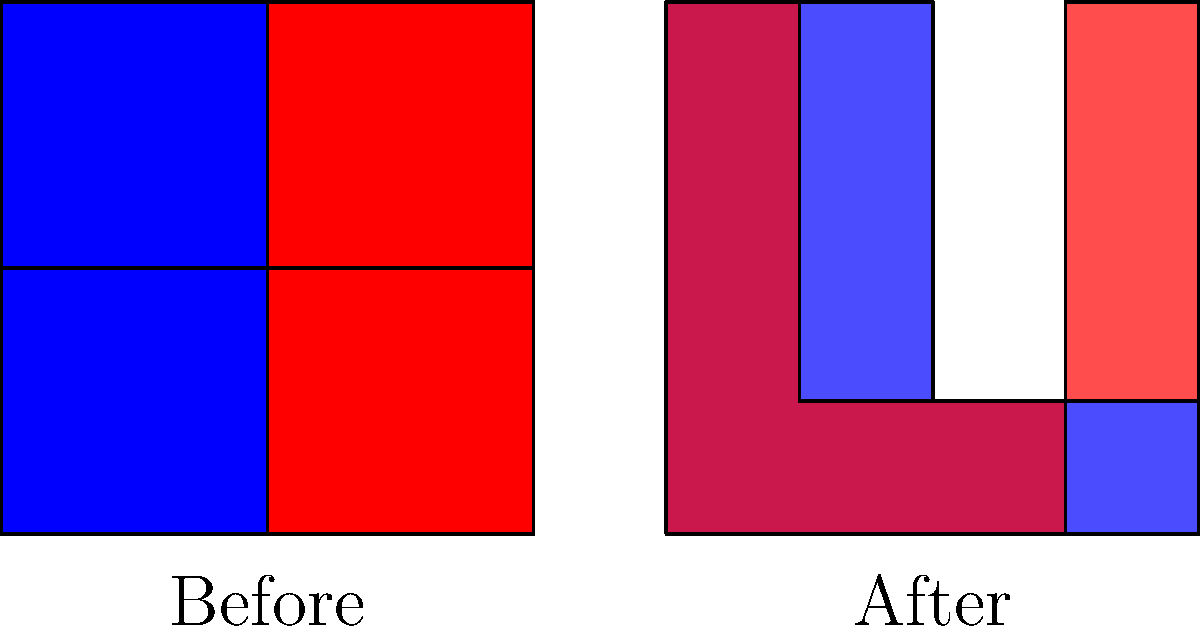How does the redistricting shown in the "After" map likely affect the representation of Democratic voters in Missouri's congressional districts compared to the "Before" map? To understand the impact of gerrymandering on Missouri's congressional districts, let's analyze the before and after maps:

1. Before map:
   - Shows four equally sized districts
   - Two districts are blue (likely Democratic-leaning)
   - Two districts are red (likely Republican-leaning)
   - This represents a balanced 2-2 split in representation

2. After map:
   - Shows two irregularly shaped districts
   - The blue district is condensed into one oddly shaped area
   - The red district surrounds and splits the blue area

3. Effects of redistricting:
   - Concentrates Democratic voters into one district (called "packing")
   - Spreads remaining Democratic voters across the red district, diluting their voting power
   - Likely results in a 1-1 split in representation, despite no change in overall voter preferences

4. Impact on Democratic representation:
   - Reduces the number of districts where Democrats have a majority
   - Decreases the likelihood of electing Democratic representatives
   - Potentially leads to underrepresentation of Democratic voters in Congress

5. Conclusion:
   The gerrymandering shown in the "After" map likely reduces Democratic representation from two seats to one seat, despite no change in the overall proportion of Democratic voters in the state.
Answer: Reduced Democratic representation 